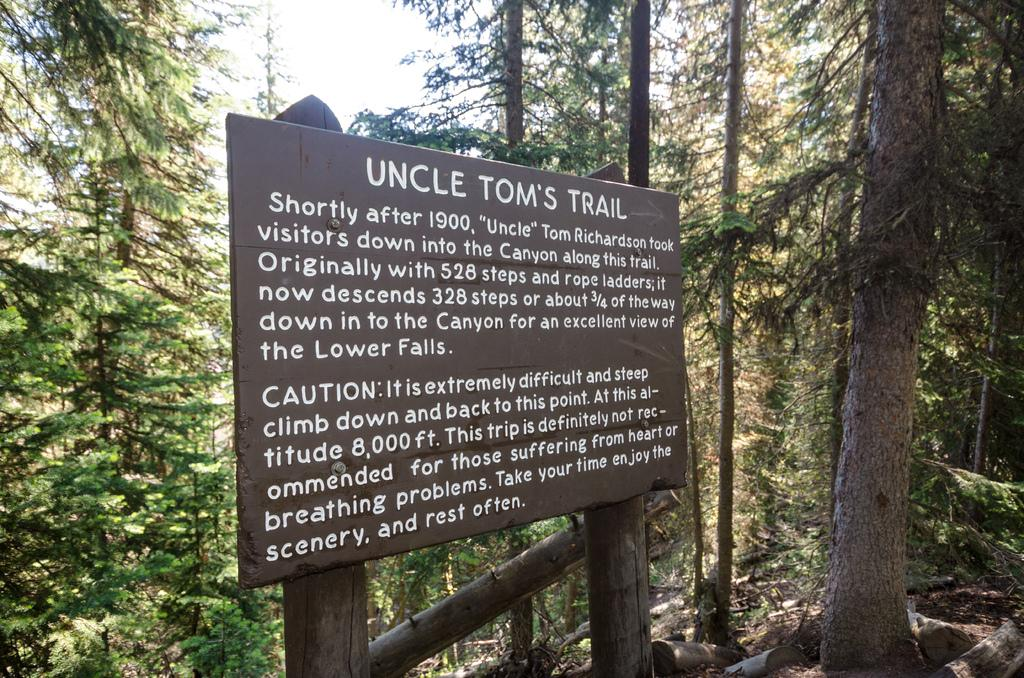What is attached to the wooden object in the image? There is a board attached to a wooden object in the image. What can be seen on the board? There is writing on the board. What type of natural environment is visible in the background of the image? There are trees in the background of the image. What else can be seen in the background of the image? The sky is visible in the background of the image. Can you tell me how many hooks are hanging from the board in the image? There are no hooks present in the image; it features a board with writing on it. What word does the grandmother say in the image? There is no grandmother or spoken word present in the image. 